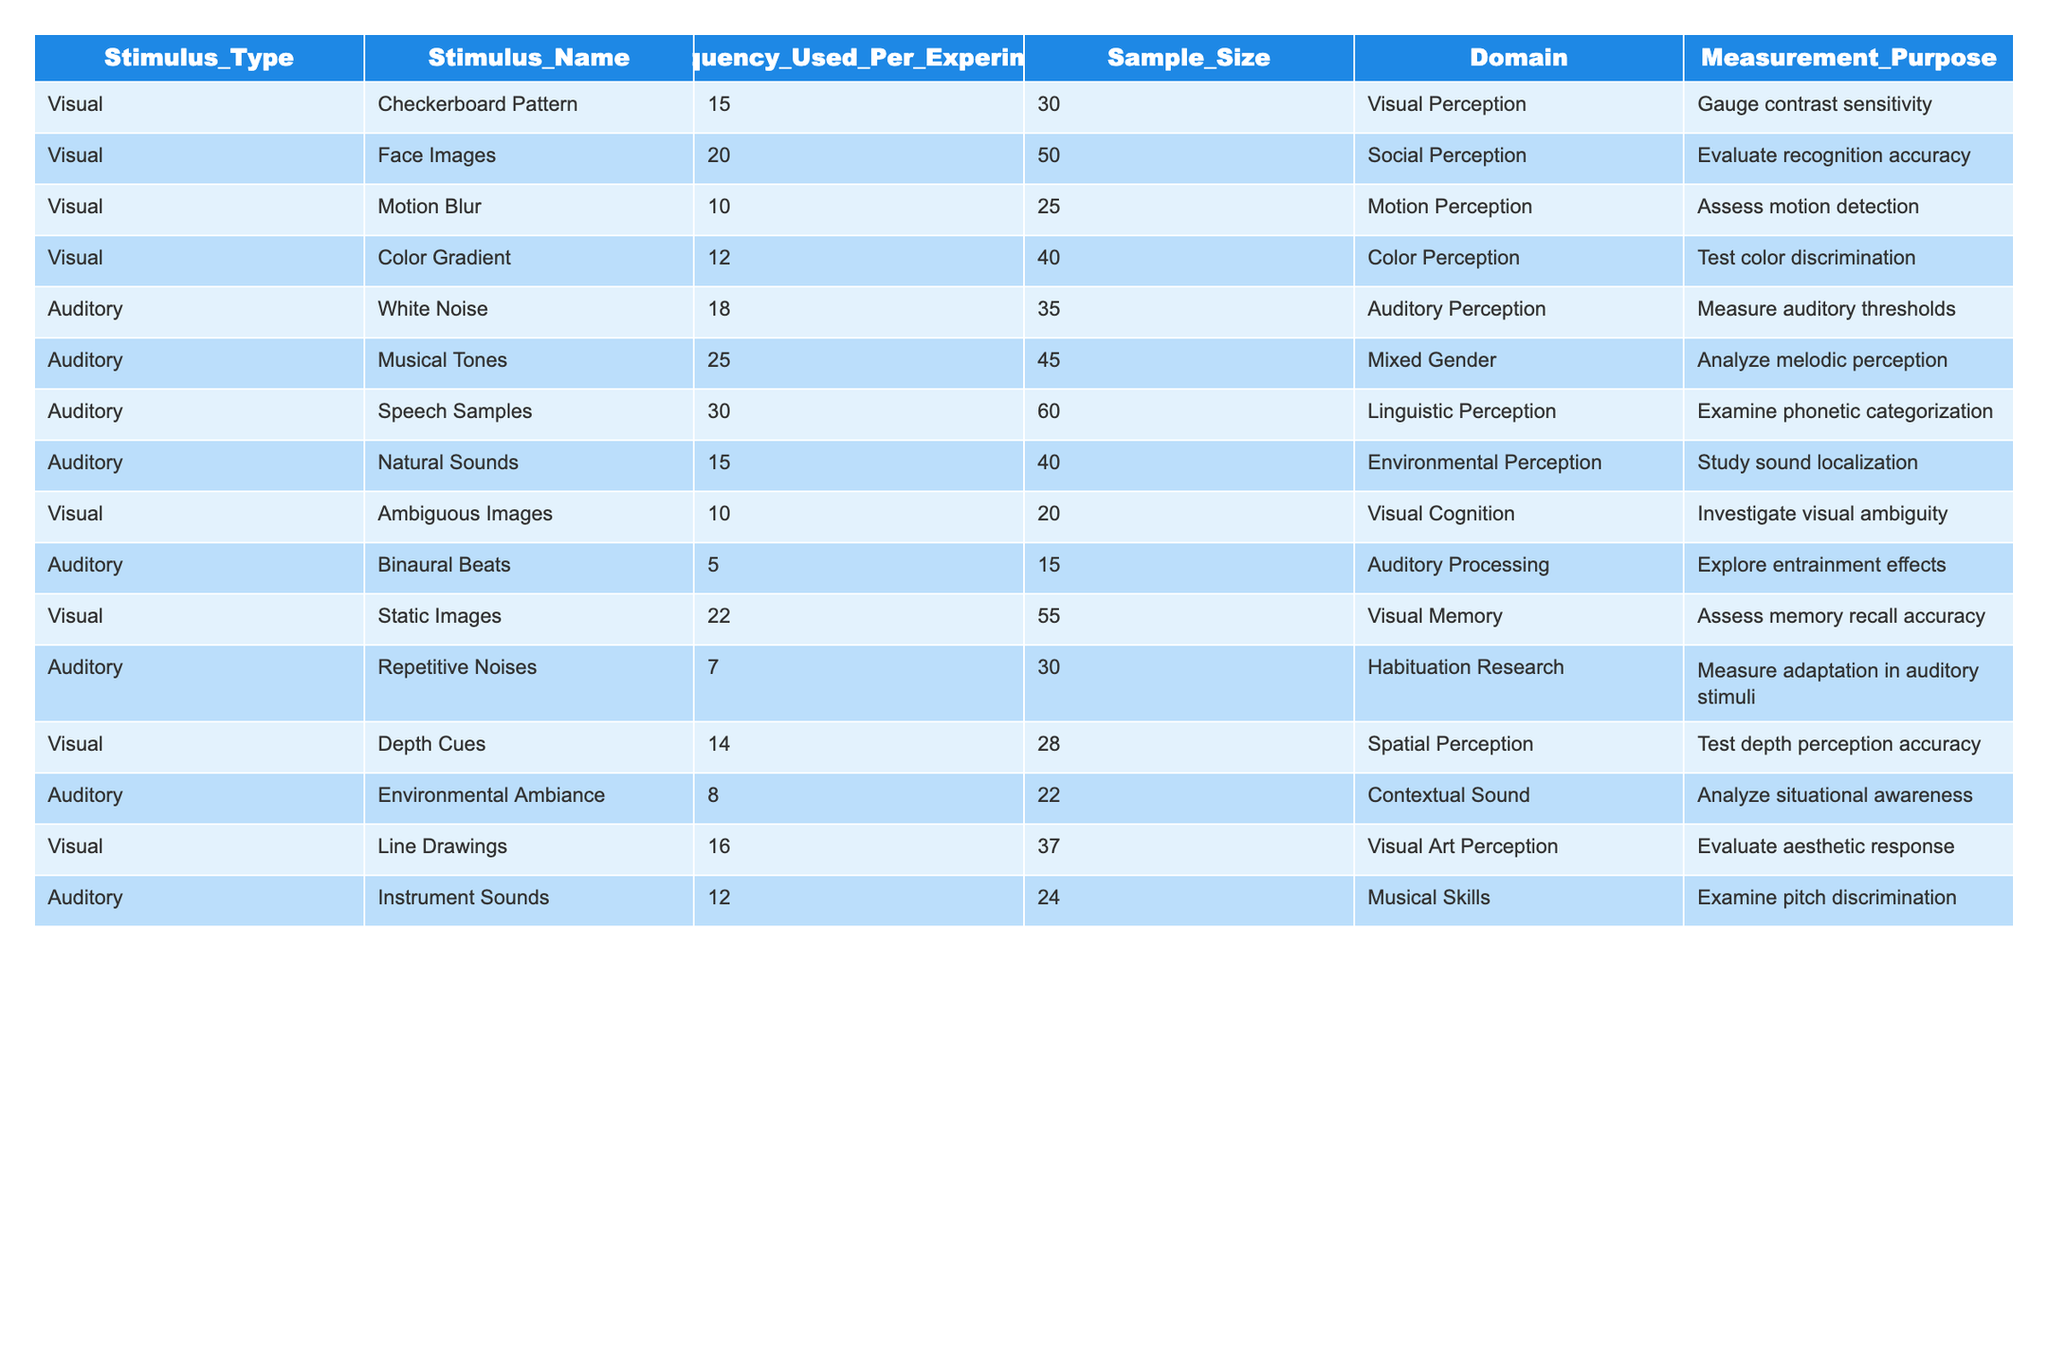What is the highest frequency of visual stimuli used in the experiments? The table shows the frequency of each visual stimulus. The highest frequency listed is for "Static Images" at 22.
Answer: 22 What is the average frequency of auditory stimuli? To find the average frequency, we sum the frequencies of all auditory stimuli (18 + 25 + 30 + 15 + 5 + 7 + 8 + 12 = 120) and divide by the number of auditory stimuli (8), resulting in 120 / 8 = 15.
Answer: 15 Is "Binaural Beats" used more frequently than "Depth Cues"? The frequency for "Binaural Beats" is 5, while "Depth Cues" has a frequency of 14. Since 5 is less than 14, the answer is no.
Answer: No Which type of stimulus has the least frequency and what is that frequency? Looking at the frequency column, "Binaural Beats" has the least frequency at 5.
Answer: 5 How many visual stimuli are used to gauge recognition accuracy? The table lists "Face Images" as the only visual stimulus that specifically mentions gauging recognition accuracy, and it is used 20 times.
Answer: 1 What is the combined frequency of all visual stimuli? The frequencies of all visual stimuli are summed up: 15 + 20 + 10 + 12 + 10 + 22 + 14 + 16 = 119.
Answer: 119 Are there more auditory stimuli focused on environmental sounds compared to any visual stimuli? "Natural Sounds" (15) and "Environmental Ambiance" (8) are auditory stimuli focused on environmental sounds, totaling 23. In comparison to visual stimuli, the maximum visual frequency is 22 for static images, so the answer is yes.
Answer: Yes What is the frequency difference between the most and least used auditory stimuli? The most used auditory stimulus is "Speech Samples" at 30, while the least used is "Binaural Beats" at 5. The difference is 30 - 5 = 25.
Answer: 25 How many different visual stimuli are tested for spatial perception accuracy? The table shows that "Depth Cues" is the only visual stimulus listed for testing spatial perception accuracy.
Answer: 1 What do the frequencies suggest about the focus of visual versus auditory stimuli in these experiments? Visual stimuli have mostly higher frequencies (highest being 22), while auditory stimuli range widely. This suggests a greater emphasis on visual perception in these experiments.
Answer: Greater emphasis on visual stimuli 